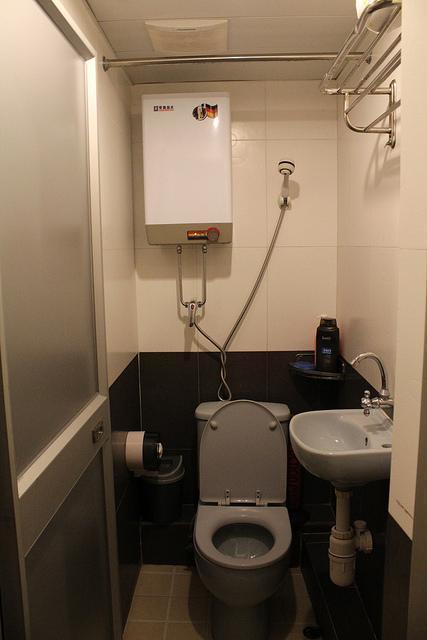How many toilets are there?
Give a very brief answer. 1. 